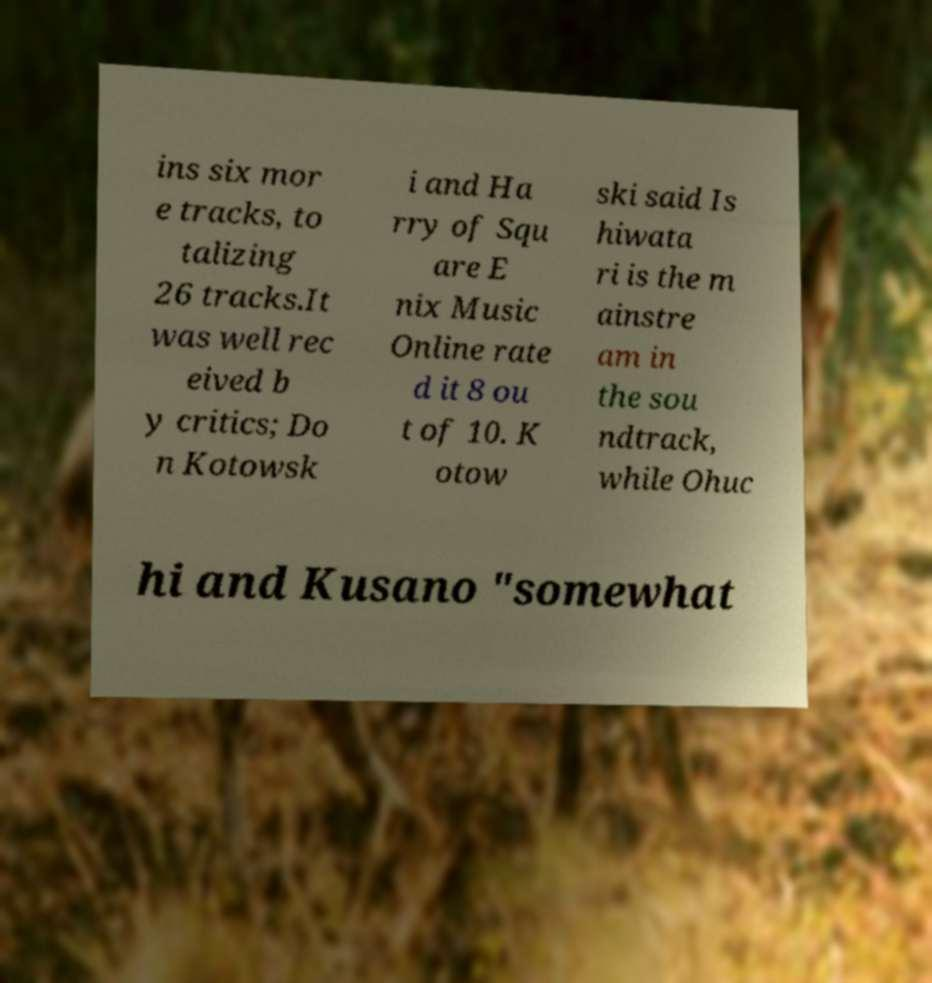Can you accurately transcribe the text from the provided image for me? ins six mor e tracks, to talizing 26 tracks.It was well rec eived b y critics; Do n Kotowsk i and Ha rry of Squ are E nix Music Online rate d it 8 ou t of 10. K otow ski said Is hiwata ri is the m ainstre am in the sou ndtrack, while Ohuc hi and Kusano "somewhat 